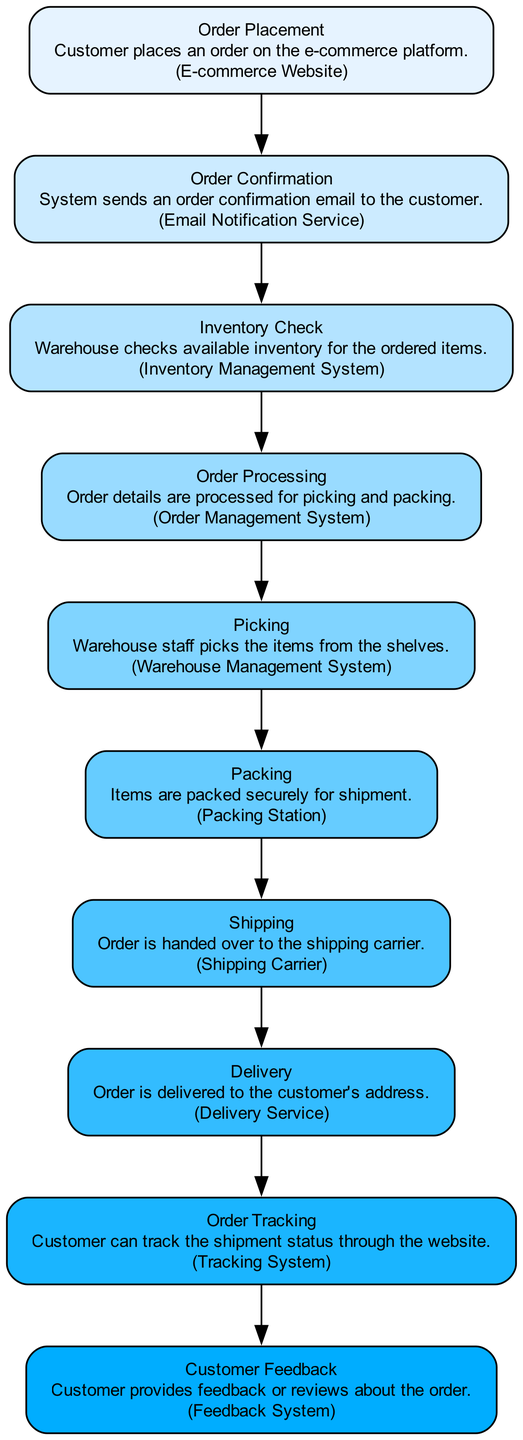What is the first step in the order fulfillment process? The diagram clearly shows that the first step is "Order Placement". The first node indicates that the customer places an order on the e-commerce platform.
Answer: Order Placement What entity performs the inventory check? According to the diagram, the "Inventory Management System" is the entity responsible for checking available inventory for the ordered items, which is detailed in the "Inventory Check" step.
Answer: Inventory Management System How many total steps are in the order fulfillment process? By counting the nodes in the diagram, I identified that there are a total of ten steps, confirming the complete flow from order placement to customer feedback.
Answer: 10 What happens right after packing the items? Following the “Packing” step in the flow chart, the next step is “Shipping”, where the order is handed over to the shipping carrier. This sequential relationship is clear from the arrow connecting the two steps.
Answer: Shipping Which step includes customer tracking? In the diagram, “Order Tracking” is the designated step that allows customers to track their shipment status through the website, highlighting its importance in the fulfillment process.
Answer: Order Tracking What is the final step in the order fulfillment process? The last node in the diagram is labeled "Customer Feedback", indicating it is the final step where the customer provides feedback or reviews about the order, closing the fulfillment loop.
Answer: Customer Feedback How are items picked for an order? The "Picking" step depicts the description that warehouse staff picks the items from the shelves, showing the action taken in this specific step of the fulfillment process.
Answer: Warehouse staff What service sends an order confirmation email? The “Email Notification Service” is identified as the service responsible for sending an order confirmation email to the customer, which occurs immediately after order placement in the flow.
Answer: Email Notification Service What step comes after inventory check? The diagram shows that after the "Inventory Check" step, the process moves to "Order Processing", where order details are processed for picking and packing.
Answer: Order Processing 